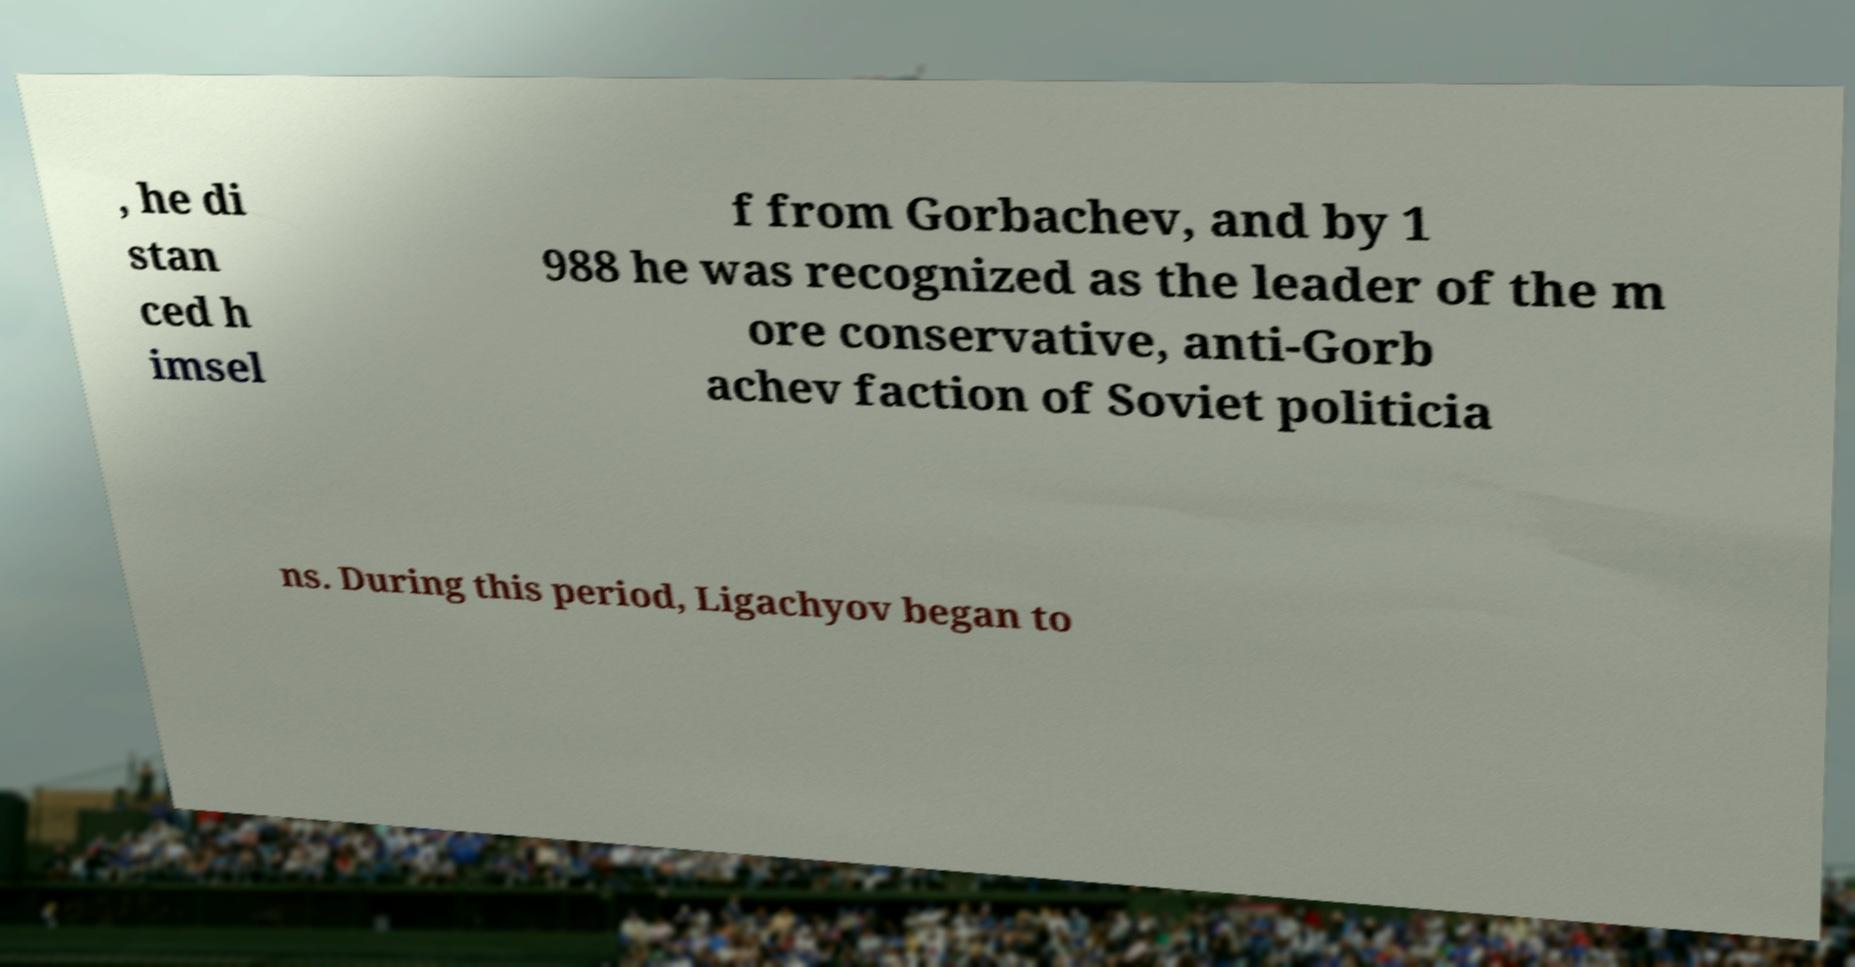There's text embedded in this image that I need extracted. Can you transcribe it verbatim? , he di stan ced h imsel f from Gorbachev, and by 1 988 he was recognized as the leader of the m ore conservative, anti-Gorb achev faction of Soviet politicia ns. During this period, Ligachyov began to 